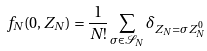Convert formula to latex. <formula><loc_0><loc_0><loc_500><loc_500>f _ { N } ( 0 , Z _ { N } ) = \frac { 1 } { N ! } \sum _ { \sigma \in \mathcal { S } _ { N } } \delta _ { Z _ { N } = \sigma Z _ { N } ^ { 0 } }</formula> 